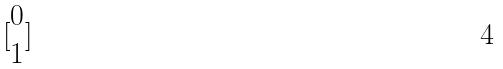<formula> <loc_0><loc_0><loc_500><loc_500>[ \begin{matrix} 0 \\ 1 \end{matrix} ]</formula> 